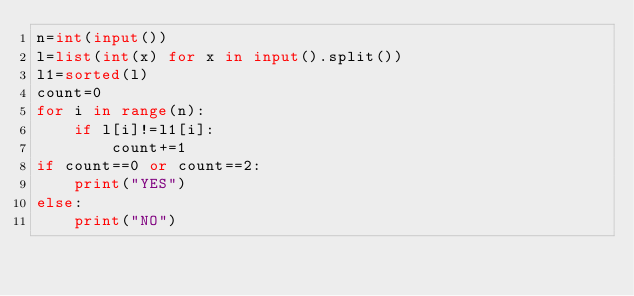Convert code to text. <code><loc_0><loc_0><loc_500><loc_500><_Python_>n=int(input())
l=list(int(x) for x in input().split())
l1=sorted(l)
count=0
for i in range(n):
    if l[i]!=l1[i]:
        count+=1
if count==0 or count==2:
    print("YES")
else:
    print("NO")
</code> 